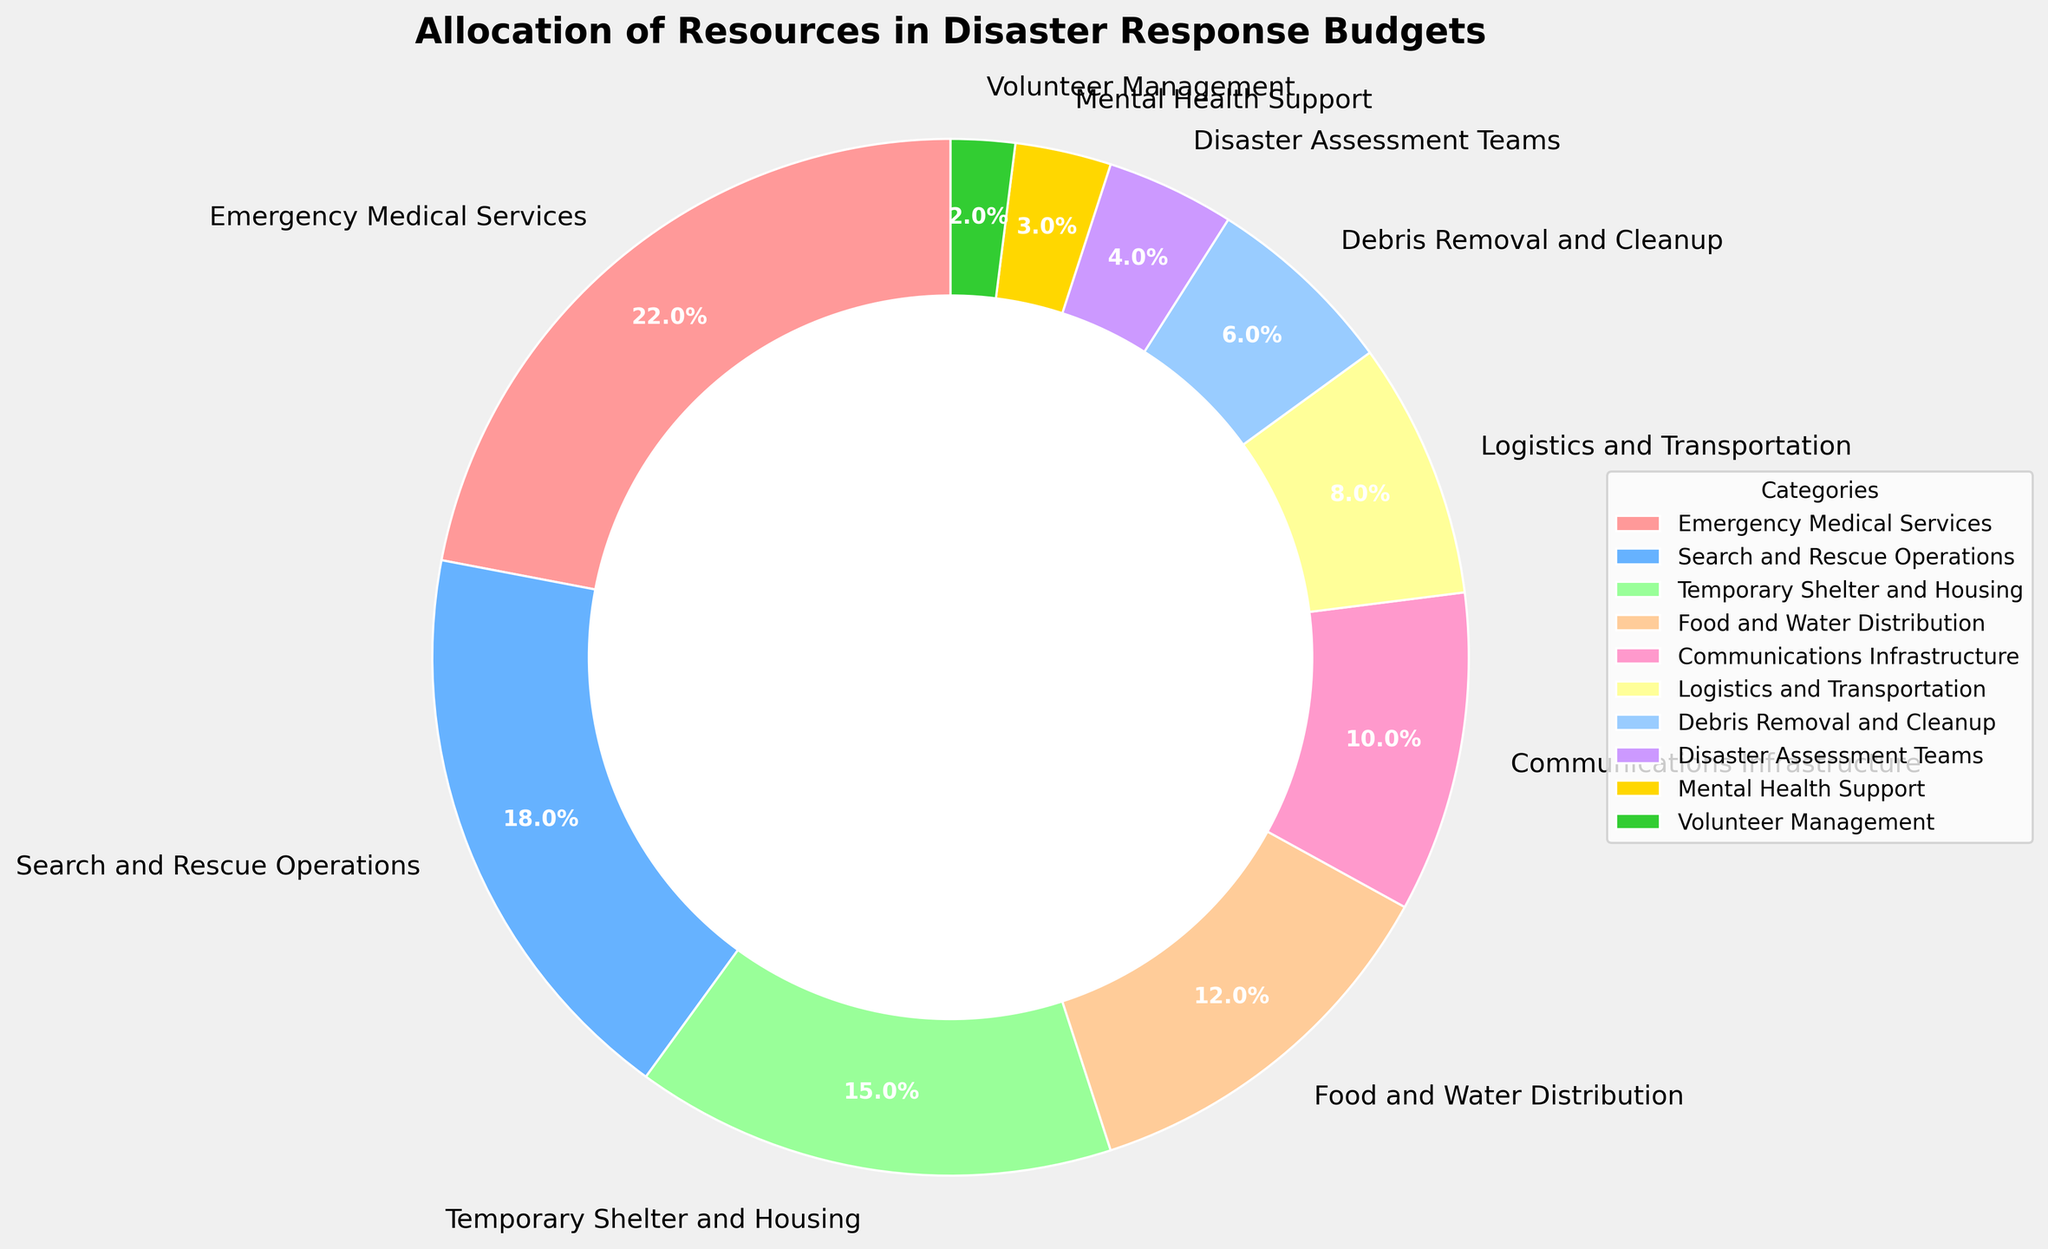What's the largest category in the disaster response budget pie chart? The largest category can be identified by looking for the wedge that represents the highest percentage. Upon observing closely, Emergency Medical Services has the largest wedge with a percentage of 22%.
Answer: Emergency Medical Services How much more percentage is allocated to Emergency Medical Services compared to Disaster Assessment Teams? To find this, subtract the percentage of Disaster Assessment Teams (4%) from that of Emergency Medical Services (22%). 22% - 4% = 18%.
Answer: 18% Which categories together make up 65% of the budget? Adding up the percentages progressively: Emergency Medical Services (22%) + Search and Rescue Operations (18%) + Temporary Shelter and Housing (15%) = 55%. Now add Food and Water Distribution (12%) to reach 67%, which is smaller than or equal to 65%. The categories are Emergency Medical Services, Search and Rescue Operations, Temporary Shelter and Housing, and Food and Water Distribution.
Answer: Emergency Medical Services, Search and Rescue Operations, Temporary Shelter and Housing, and Food and Water Distribution Which color represents Food and Water Distribution in the pie chart? The color legend in the chart shows that Food and Water Distribution is represented by the fourth color in the sequence, which is a light orange color.
Answer: light orange What is the combined percentage of Logistics and Transportation and Communications Infrastructure? Adding the percentages of Logistics and Transportation (8%) and Communications Infrastructure (10%) results in 8% + 10% = 18%.
Answer: 18% How does the percentage allocated to Mental Health Support compare to Communications Infrastructure? Mental Health Support is at 3%, while Communications Infrastructure is at 10%. By comparing them, it can be observed that Communications Infrastructure is significantly larger.
Answer: Mental Health Support is 7% less than Communications Infrastructure If the budget for Volunteer Management was doubled, what would its new percentage allocation be? Currently, Volunteer Management is 2%. Doubling it will be 2% x 2 = 4%.
Answer: 4% What percentage of the disaster response budget is allocated to Food and Water Distribution compared to Temporary Shelter and Housing? To compare, observe that Food and Water Distribution is at 12% and Temporary Shelter and Housing is at 15%.
Answer: Food and Water Distribution is 3% less than Temporary Shelter and Housing 